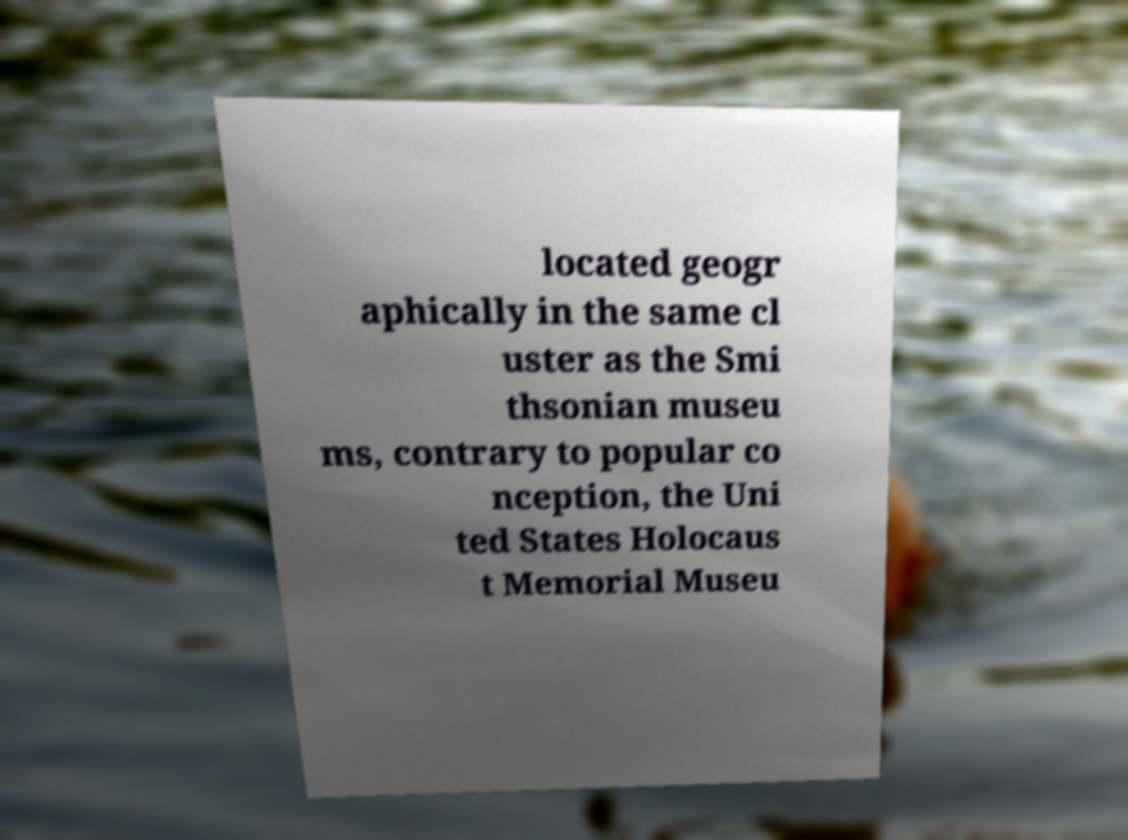Could you assist in decoding the text presented in this image and type it out clearly? located geogr aphically in the same cl uster as the Smi thsonian museu ms, contrary to popular co nception, the Uni ted States Holocaus t Memorial Museu 